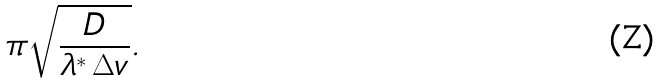<formula> <loc_0><loc_0><loc_500><loc_500>\pi \sqrt { \frac { D } { \lambda ^ { * } \, \Delta v } } .</formula> 